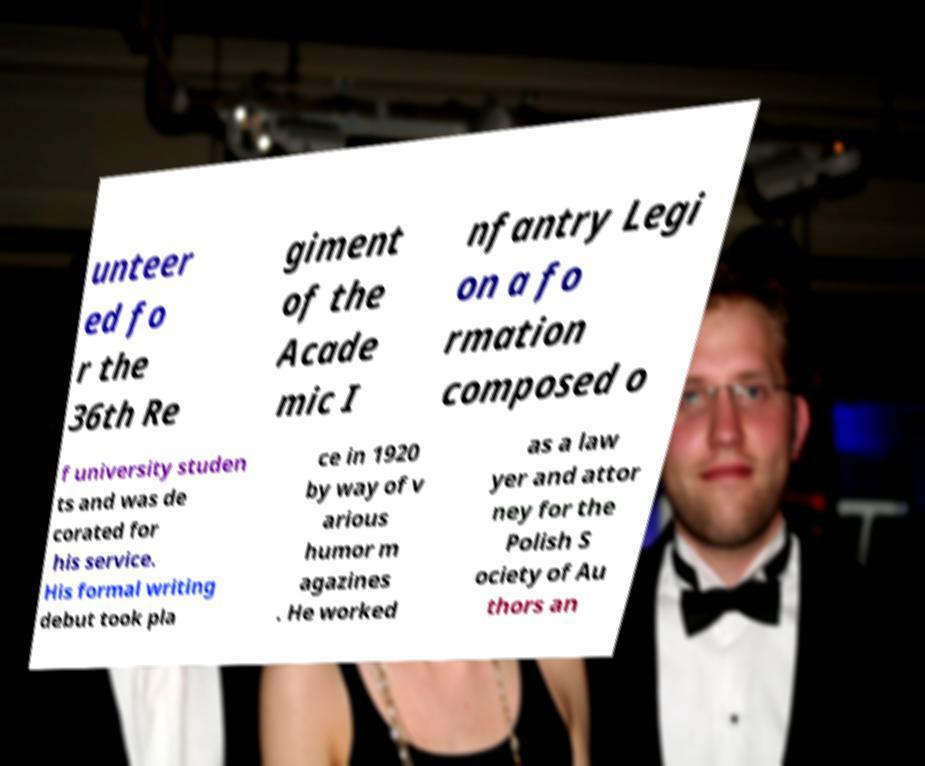For documentation purposes, I need the text within this image transcribed. Could you provide that? unteer ed fo r the 36th Re giment of the Acade mic I nfantry Legi on a fo rmation composed o f university studen ts and was de corated for his service. His formal writing debut took pla ce in 1920 by way of v arious humor m agazines . He worked as a law yer and attor ney for the Polish S ociety of Au thors an 